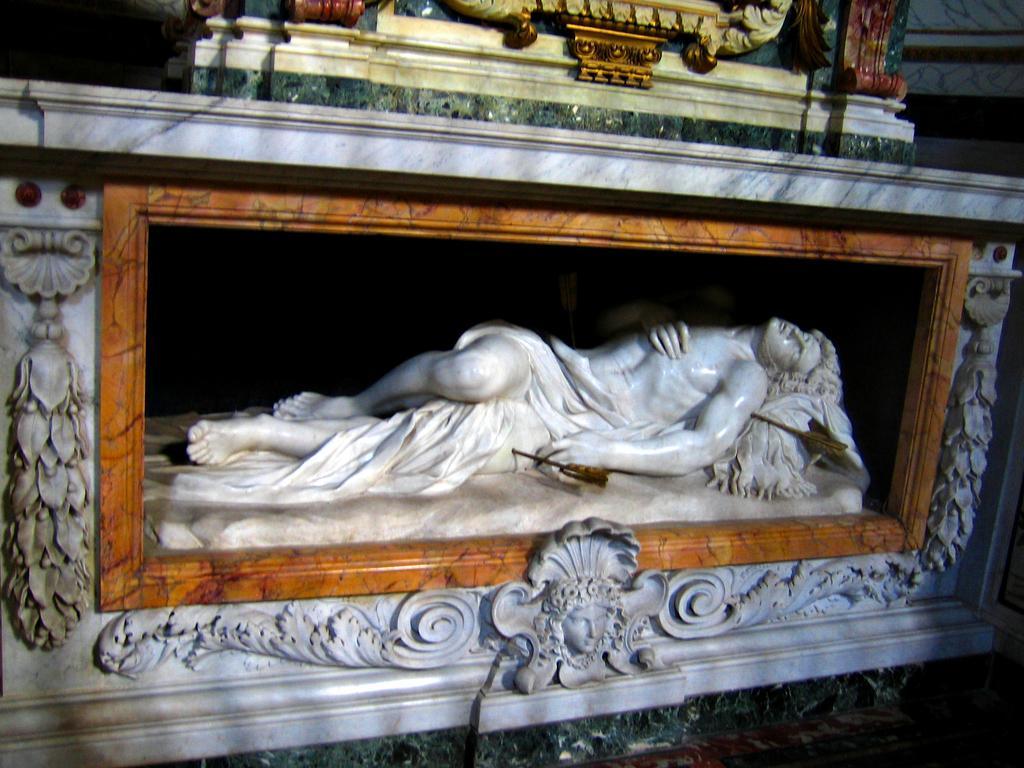Can you describe this image briefly? In the picture there is a statue present. 